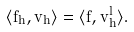<formula> <loc_0><loc_0><loc_500><loc_500>\langle f _ { h } , v _ { h } \rangle = \langle f , v _ { h } ^ { l } \rangle .</formula> 